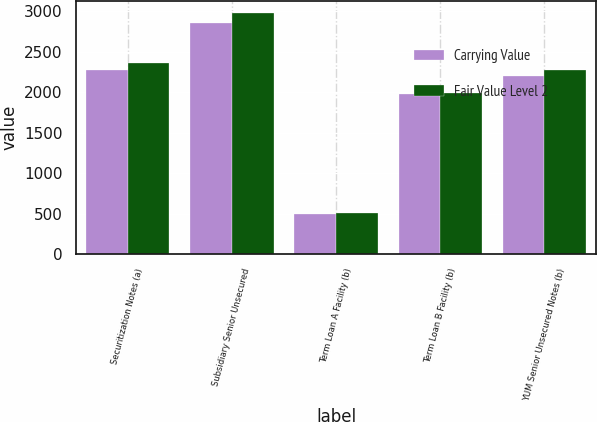Convert chart to OTSL. <chart><loc_0><loc_0><loc_500><loc_500><stacked_bar_chart><ecel><fcel>Securitization Notes (a)<fcel>Subsidiary Senior Unsecured<fcel>Term Loan A Facility (b)<fcel>Term Loan B Facility (b)<fcel>YUM Senior Unsecured Notes (b)<nl><fcel>Carrying Value<fcel>2271<fcel>2850<fcel>500<fcel>1975<fcel>2200<nl><fcel>Fair Value Level 2<fcel>2367<fcel>2983<fcel>503<fcel>1990<fcel>2277<nl></chart> 